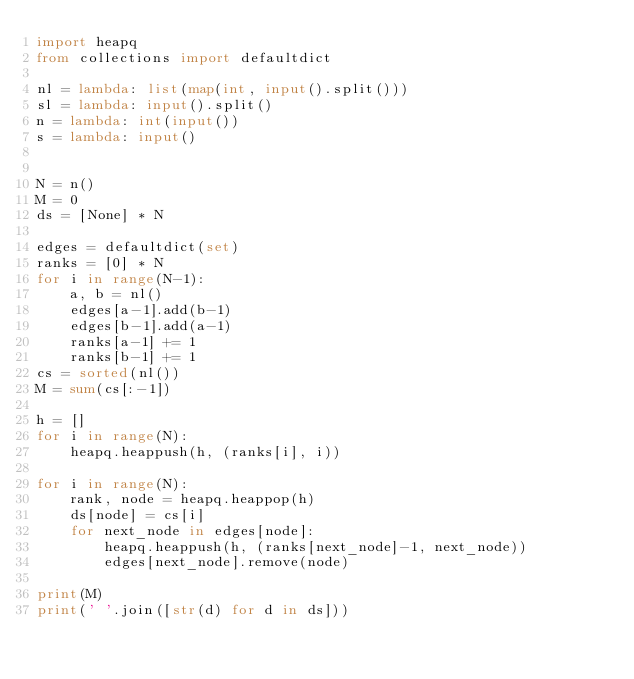<code> <loc_0><loc_0><loc_500><loc_500><_Python_>import heapq
from collections import defaultdict

nl = lambda: list(map(int, input().split()))
sl = lambda: input().split()
n = lambda: int(input())
s = lambda: input()


N = n()
M = 0
ds = [None] * N

edges = defaultdict(set)
ranks = [0] * N
for i in range(N-1):
    a, b = nl()
    edges[a-1].add(b-1)
    edges[b-1].add(a-1)
    ranks[a-1] += 1
    ranks[b-1] += 1
cs = sorted(nl())
M = sum(cs[:-1])

h = []
for i in range(N):
    heapq.heappush(h, (ranks[i], i))

for i in range(N):
    rank, node = heapq.heappop(h)
    ds[node] = cs[i]
    for next_node in edges[node]:
        heapq.heappush(h, (ranks[next_node]-1, next_node))
        edges[next_node].remove(node)

print(M)
print(' '.join([str(d) for d in ds]))
</code> 